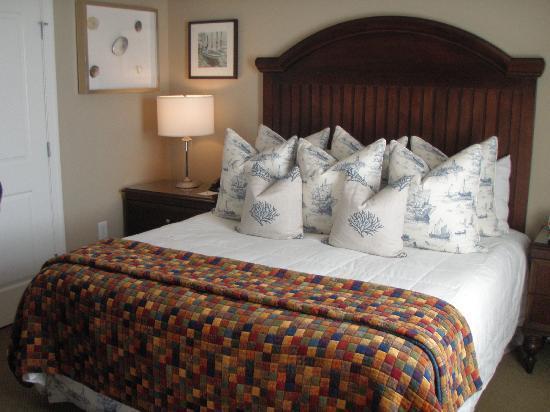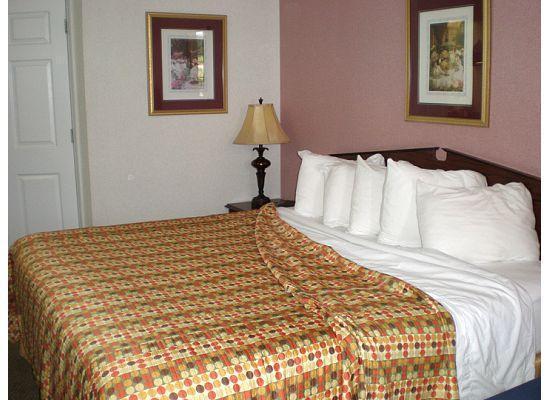The first image is the image on the left, the second image is the image on the right. Evaluate the accuracy of this statement regarding the images: "At least one of the beds has a grey headboard.". Is it true? Answer yes or no. No. 